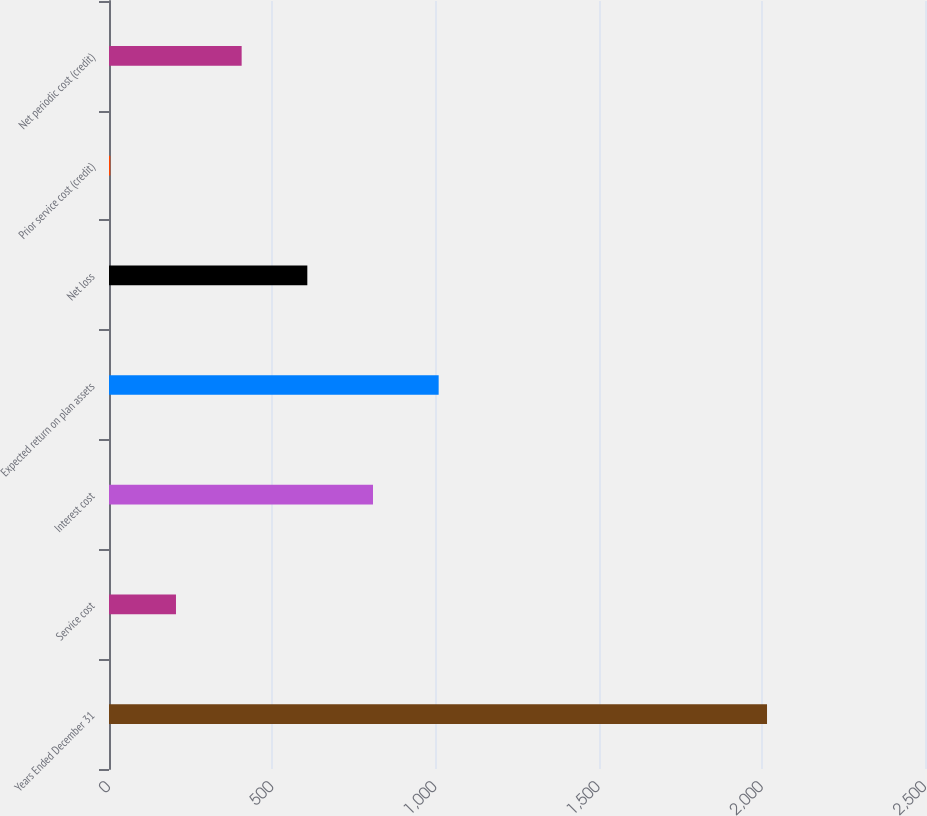Convert chart to OTSL. <chart><loc_0><loc_0><loc_500><loc_500><bar_chart><fcel>Years Ended December 31<fcel>Service cost<fcel>Interest cost<fcel>Expected return on plan assets<fcel>Net loss<fcel>Prior service cost (credit)<fcel>Net periodic cost (credit)<nl><fcel>2016<fcel>205.2<fcel>808.8<fcel>1010<fcel>607.6<fcel>4<fcel>406.4<nl></chart> 